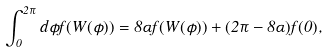<formula> <loc_0><loc_0><loc_500><loc_500>\int _ { 0 } ^ { 2 \pi } d { \phi } f ( W ( \phi ) ) = 8 \alpha f ( W ( \phi ) ) + ( 2 \pi - 8 \alpha ) f ( 0 ) ,</formula> 